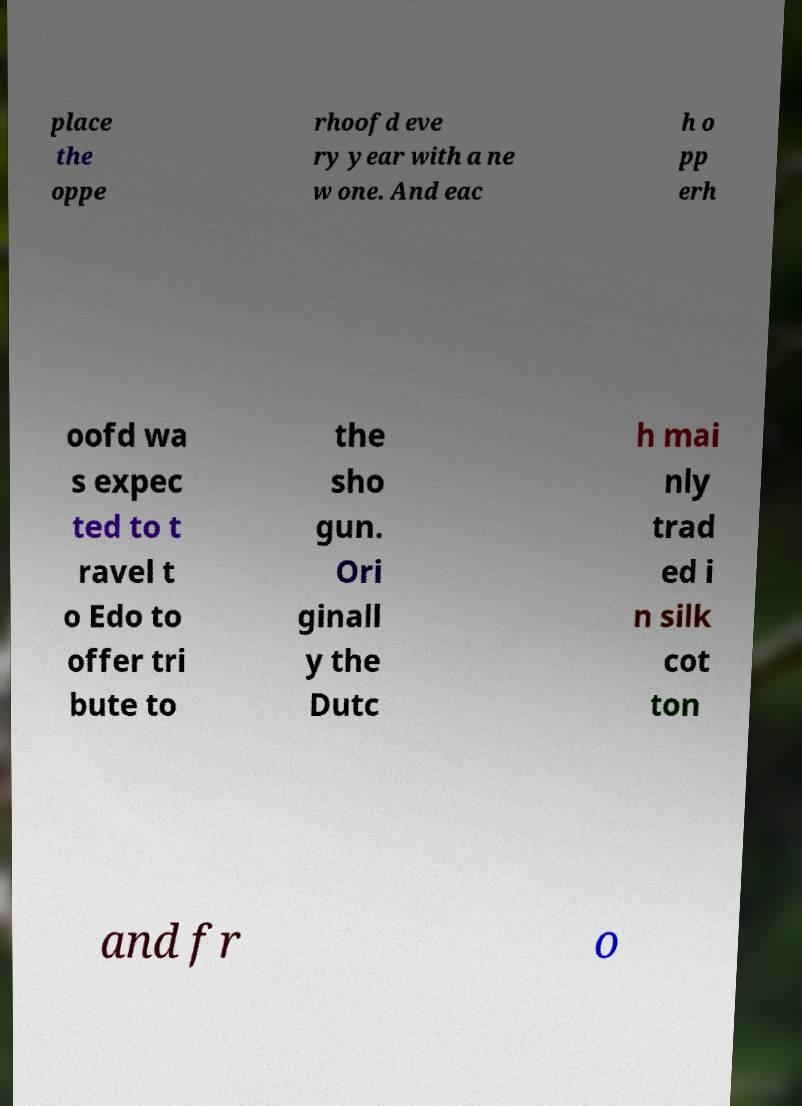What messages or text are displayed in this image? I need them in a readable, typed format. place the oppe rhoofd eve ry year with a ne w one. And eac h o pp erh oofd wa s expec ted to t ravel t o Edo to offer tri bute to the sho gun. Ori ginall y the Dutc h mai nly trad ed i n silk cot ton and fr o 